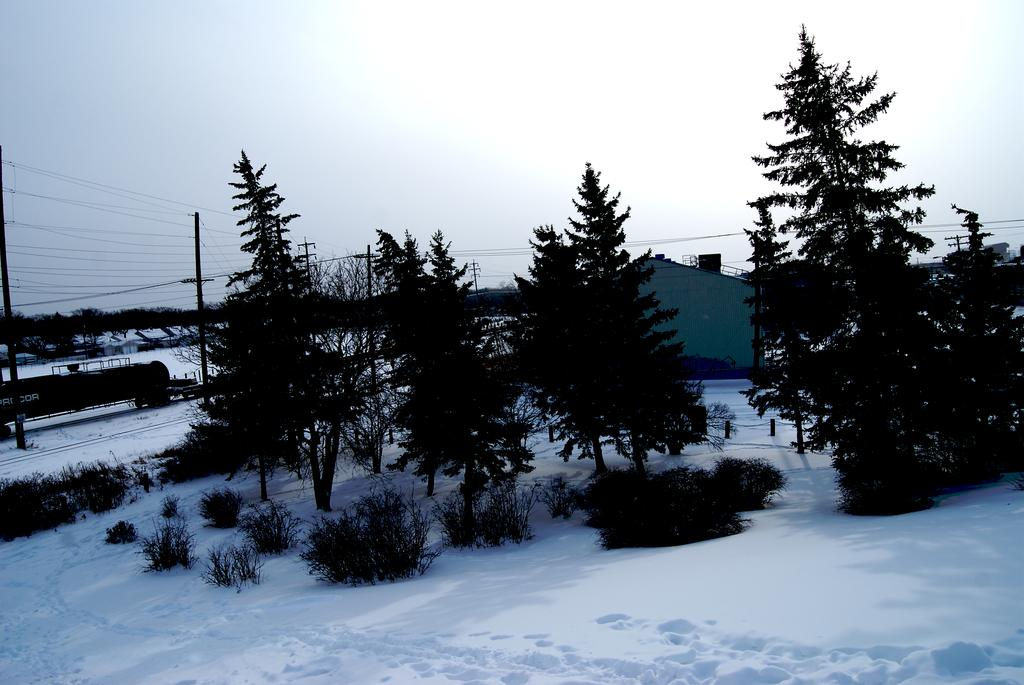What type of vegetation can be seen in the image? There are trees and plants visible in the image. What is the weather like in the image? There is snow visible in the image, indicating a cold or wintery weather. What structures can be seen in the background of the image? There is a house, poles, and wires visible in the background of the image. Can you describe the sky in the image? The sky in the background of the image has clouds. What is the shape of the object on the left side of the image? There is a cylindrical object on the left side of the image. What is the taste of the hand in the image? There is no hand present in the image, and therefore no taste can be associated with it. What type of fruit is the quince in the image? There is no quince present in the image. 